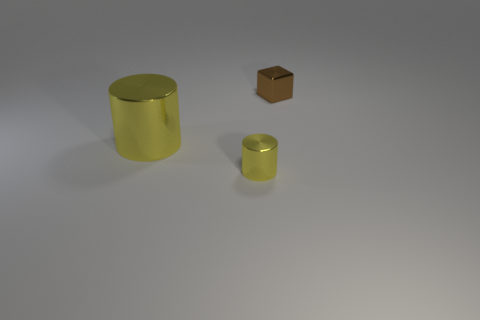How many metal things are behind the large yellow metal thing and in front of the large metal thing? There are no metal objects located behind the large yellow cylindrical item and in front of the large metal cylinder. The only other object is a small brown cube situated to the side, not fitting the described positional criteria. 